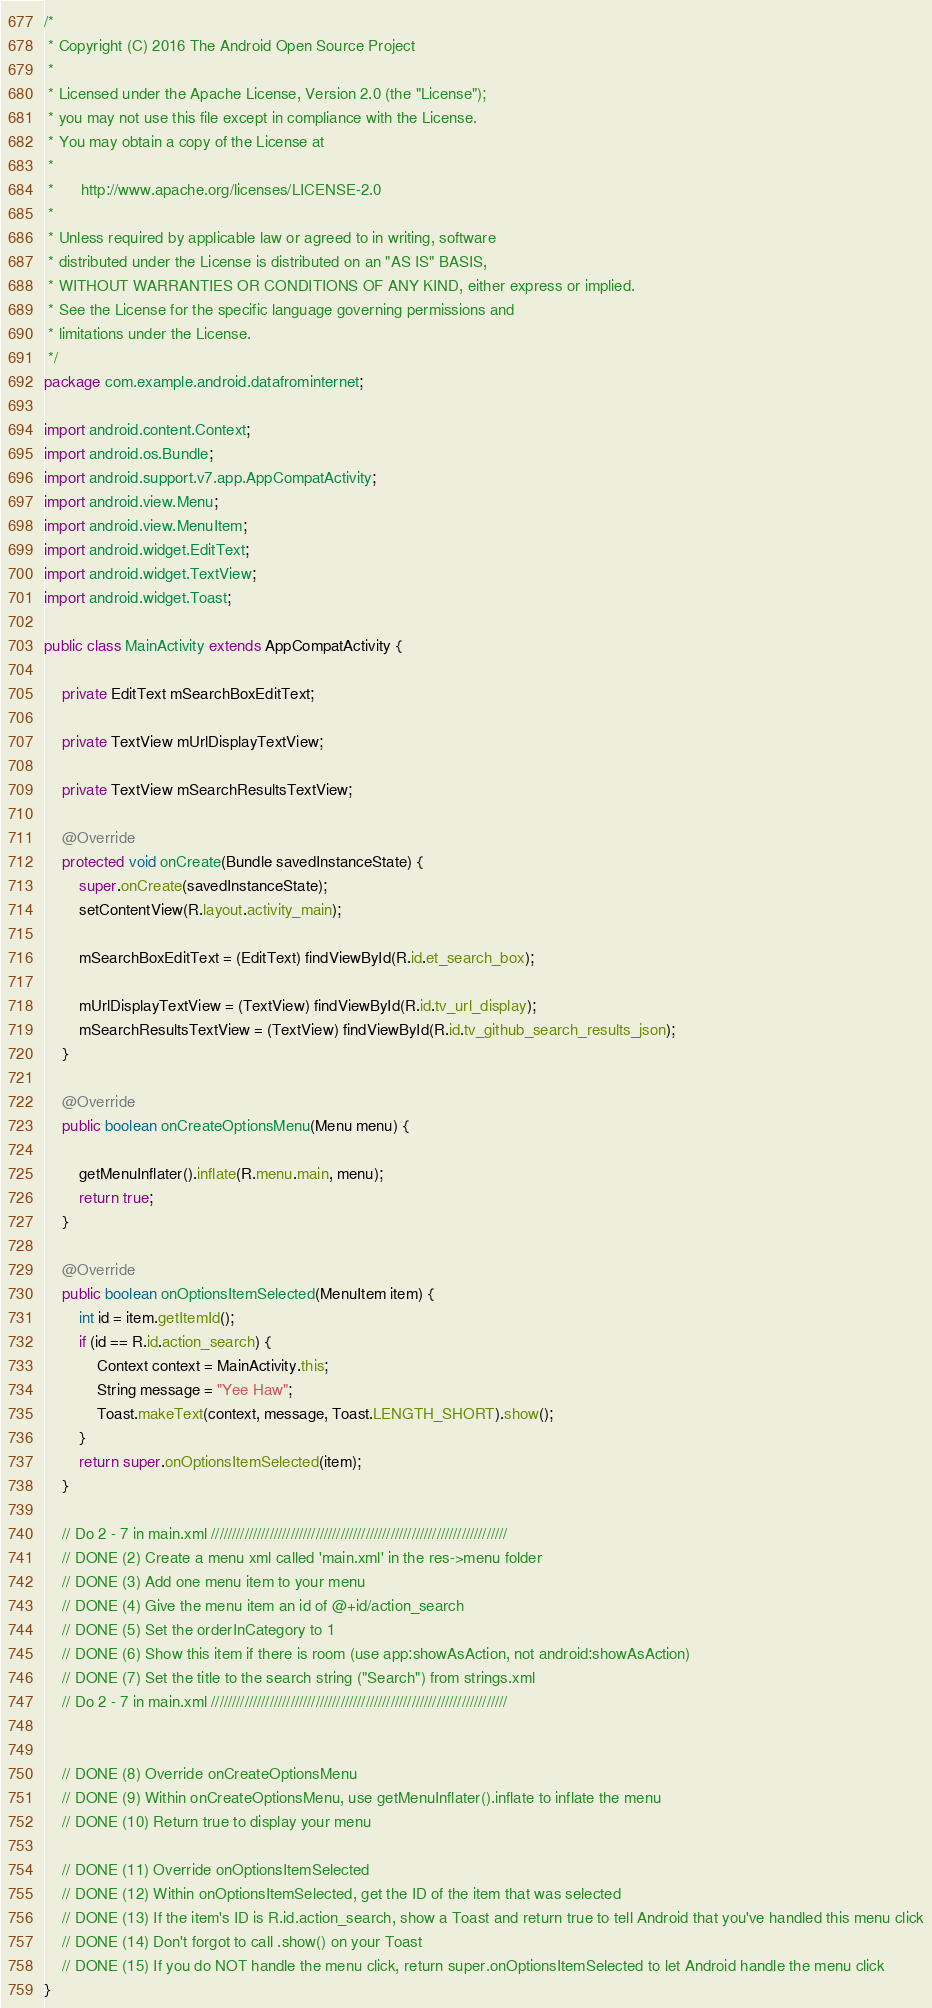Convert code to text. <code><loc_0><loc_0><loc_500><loc_500><_Java_>/*
 * Copyright (C) 2016 The Android Open Source Project
 *
 * Licensed under the Apache License, Version 2.0 (the "License");
 * you may not use this file except in compliance with the License.
 * You may obtain a copy of the License at
 *
 *      http://www.apache.org/licenses/LICENSE-2.0
 *
 * Unless required by applicable law or agreed to in writing, software
 * distributed under the License is distributed on an "AS IS" BASIS,
 * WITHOUT WARRANTIES OR CONDITIONS OF ANY KIND, either express or implied.
 * See the License for the specific language governing permissions and
 * limitations under the License.
 */
package com.example.android.datafrominternet;

import android.content.Context;
import android.os.Bundle;
import android.support.v7.app.AppCompatActivity;
import android.view.Menu;
import android.view.MenuItem;
import android.widget.EditText;
import android.widget.TextView;
import android.widget.Toast;

public class MainActivity extends AppCompatActivity {

    private EditText mSearchBoxEditText;

    private TextView mUrlDisplayTextView;

    private TextView mSearchResultsTextView;

    @Override
    protected void onCreate(Bundle savedInstanceState) {
        super.onCreate(savedInstanceState);
        setContentView(R.layout.activity_main);

        mSearchBoxEditText = (EditText) findViewById(R.id.et_search_box);

        mUrlDisplayTextView = (TextView) findViewById(R.id.tv_url_display);
        mSearchResultsTextView = (TextView) findViewById(R.id.tv_github_search_results_json);
    }

    @Override
    public boolean onCreateOptionsMenu(Menu menu) {

        getMenuInflater().inflate(R.menu.main, menu);
        return true;
    }

    @Override
    public boolean onOptionsItemSelected(MenuItem item) {
        int id = item.getItemId();
        if (id == R.id.action_search) {
            Context context = MainActivity.this;
            String message = "Yee Haw";
            Toast.makeText(context, message, Toast.LENGTH_SHORT).show();
        }
        return super.onOptionsItemSelected(item);
    }

    // Do 2 - 7 in main.xml ///////////////////////////////////////////////////////////////////////
    // DONE (2) Create a menu xml called 'main.xml' in the res->menu folder
    // DONE (3) Add one menu item to your menu
    // DONE (4) Give the menu item an id of @+id/action_search
    // DONE (5) Set the orderInCategory to 1
    // DONE (6) Show this item if there is room (use app:showAsAction, not android:showAsAction)
    // DONE (7) Set the title to the search string ("Search") from strings.xml
    // Do 2 - 7 in main.xml ///////////////////////////////////////////////////////////////////////


    // DONE (8) Override onCreateOptionsMenu
    // DONE (9) Within onCreateOptionsMenu, use getMenuInflater().inflate to inflate the menu
    // DONE (10) Return true to display your menu

    // DONE (11) Override onOptionsItemSelected
    // DONE (12) Within onOptionsItemSelected, get the ID of the item that was selected
    // DONE (13) If the item's ID is R.id.action_search, show a Toast and return true to tell Android that you've handled this menu click
    // DONE (14) Don't forgot to call .show() on your Toast
    // DONE (15) If you do NOT handle the menu click, return super.onOptionsItemSelected to let Android handle the menu click
}
</code> 